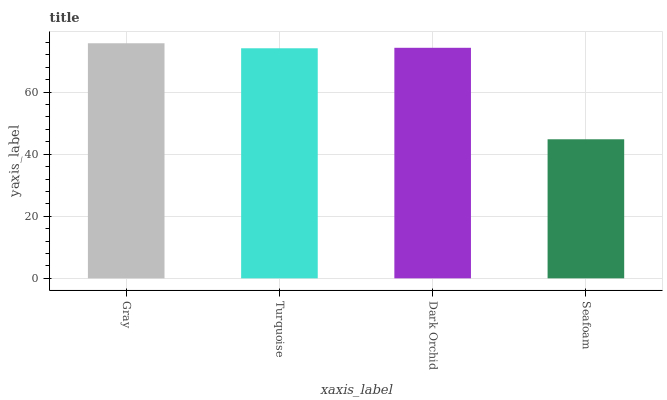Is Seafoam the minimum?
Answer yes or no. Yes. Is Gray the maximum?
Answer yes or no. Yes. Is Turquoise the minimum?
Answer yes or no. No. Is Turquoise the maximum?
Answer yes or no. No. Is Gray greater than Turquoise?
Answer yes or no. Yes. Is Turquoise less than Gray?
Answer yes or no. Yes. Is Turquoise greater than Gray?
Answer yes or no. No. Is Gray less than Turquoise?
Answer yes or no. No. Is Dark Orchid the high median?
Answer yes or no. Yes. Is Turquoise the low median?
Answer yes or no. Yes. Is Gray the high median?
Answer yes or no. No. Is Gray the low median?
Answer yes or no. No. 